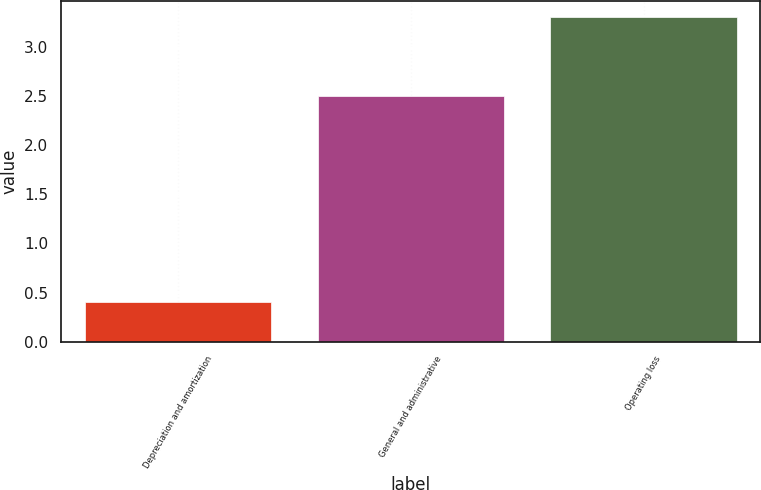Convert chart to OTSL. <chart><loc_0><loc_0><loc_500><loc_500><bar_chart><fcel>Depreciation and amortization<fcel>General and administrative<fcel>Operating loss<nl><fcel>0.4<fcel>2.5<fcel>3.3<nl></chart> 